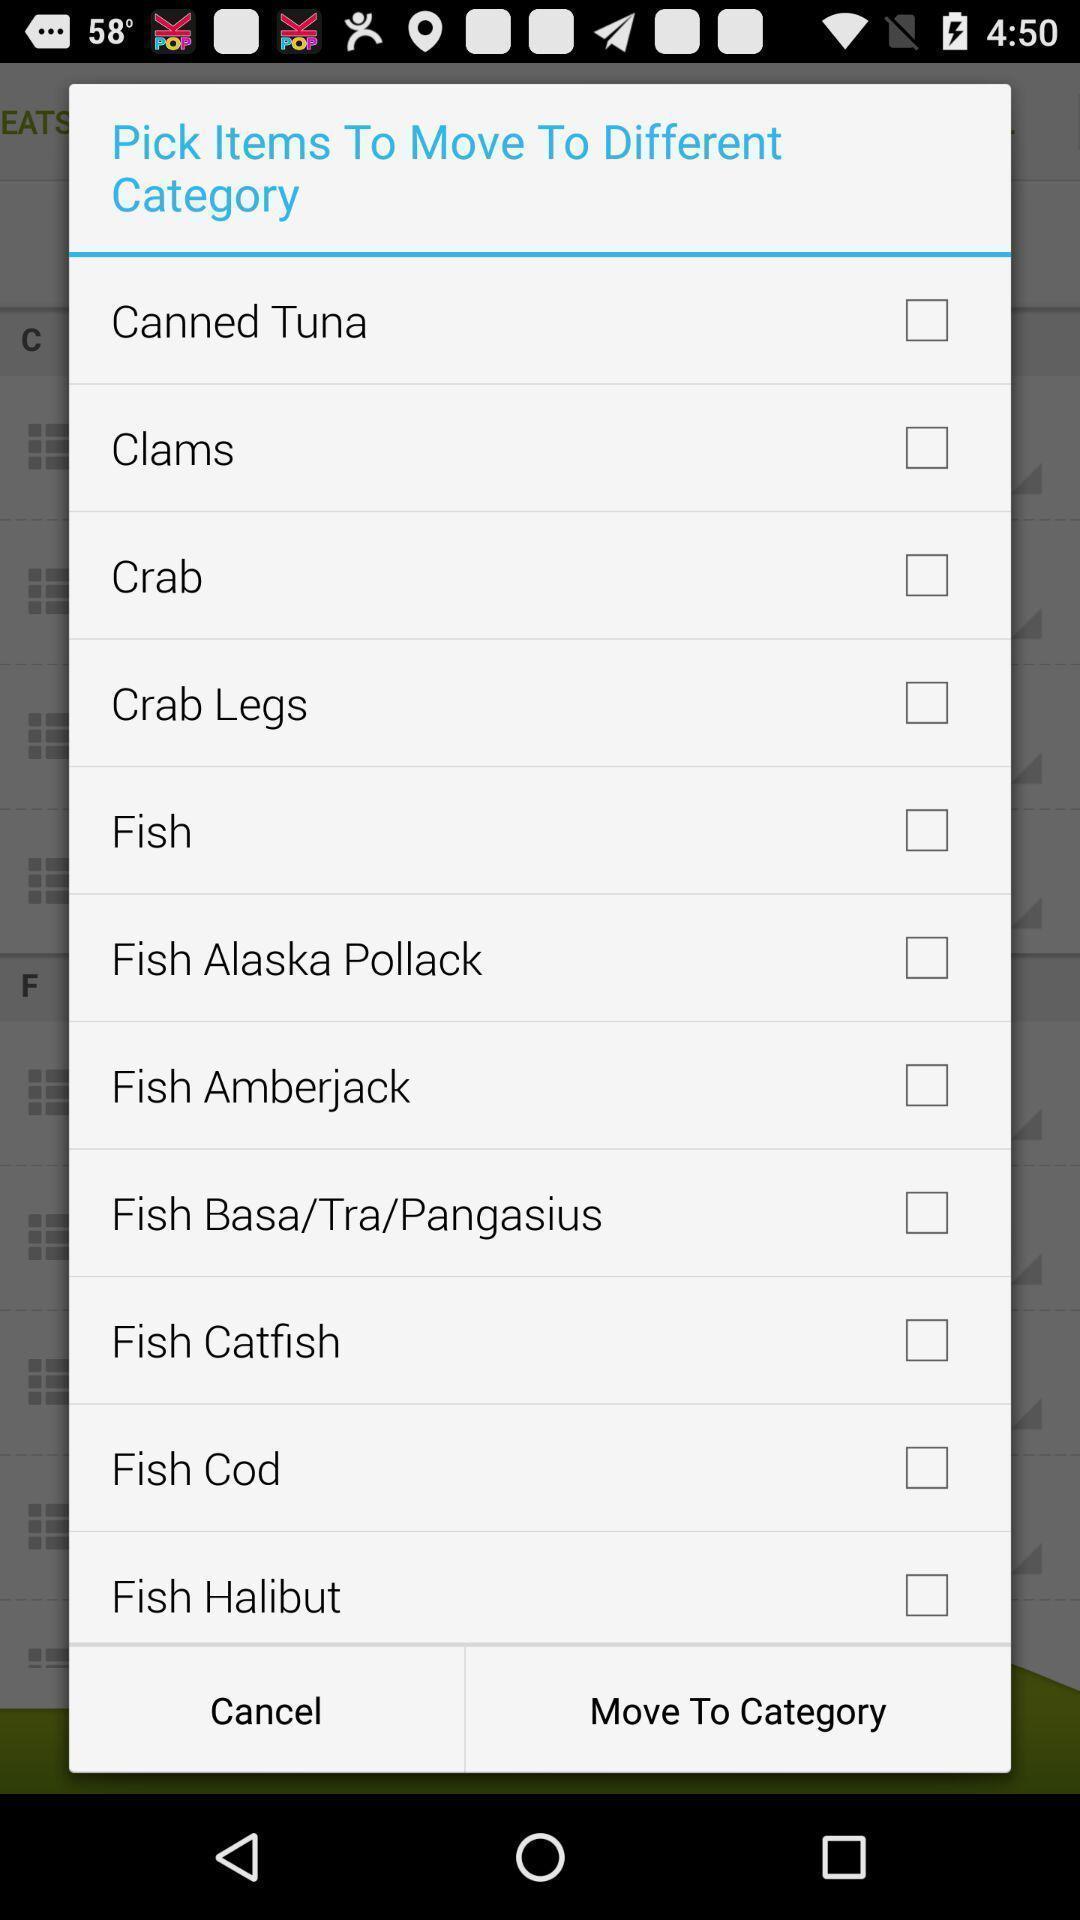What is the overall content of this screenshot? Popup checklist for food items. 